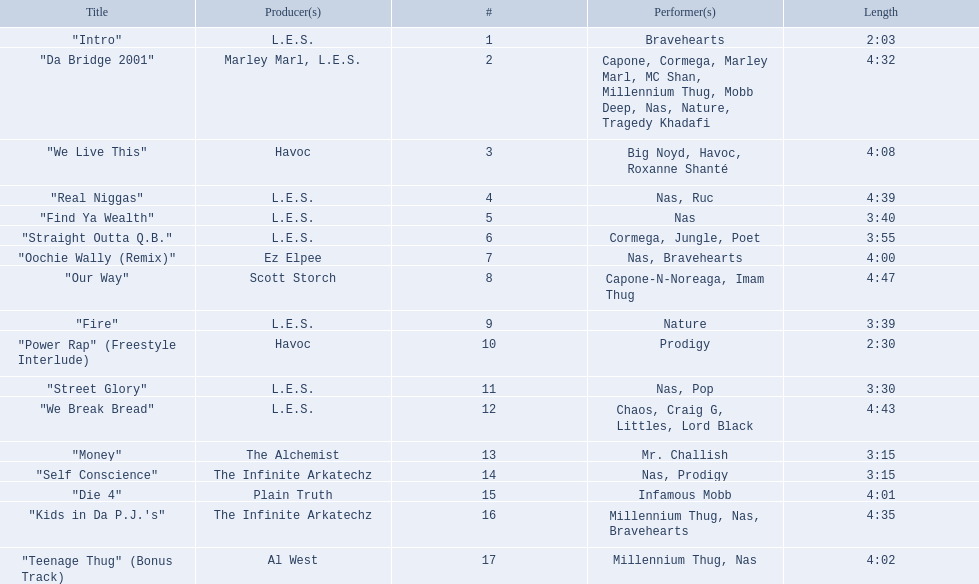How long is each song? 2:03, 4:32, 4:08, 4:39, 3:40, 3:55, 4:00, 4:47, 3:39, 2:30, 3:30, 4:43, 3:15, 3:15, 4:01, 4:35, 4:02. Of those, which length is the shortest? 2:03. 